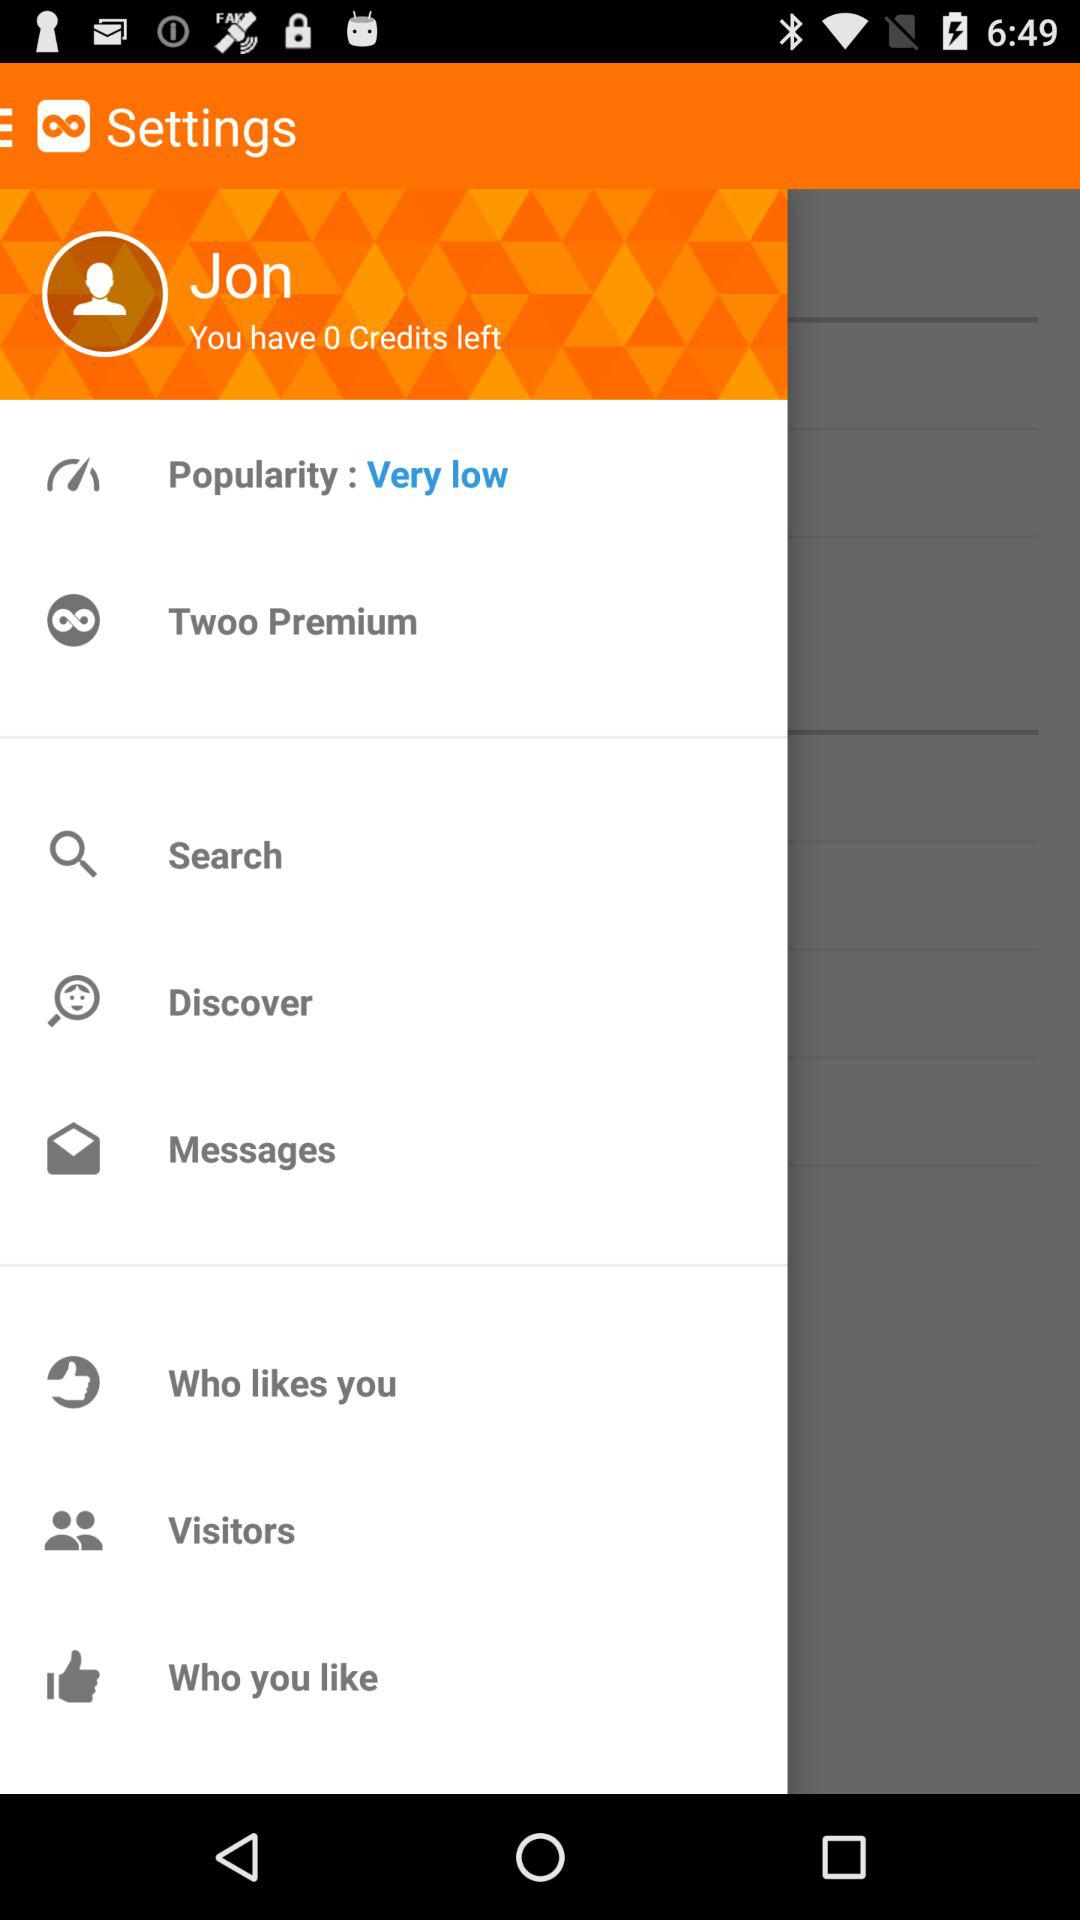How many credits does Jon have?
Answer the question using a single word or phrase. 0 